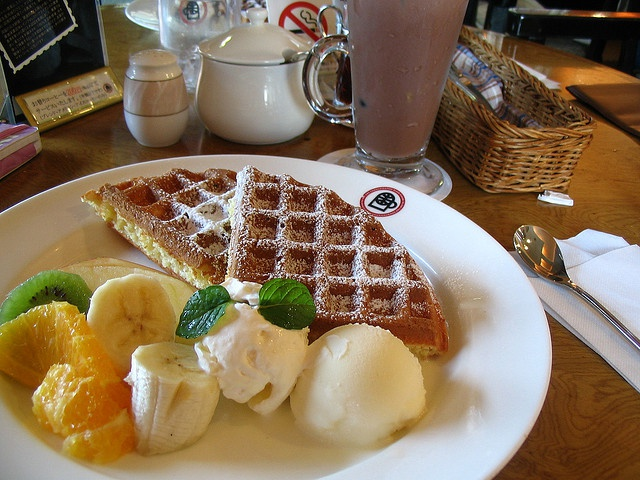Describe the objects in this image and their specific colors. I can see dining table in black, maroon, brown, and lavender tones, cake in black, maroon, lightgray, gray, and darkgray tones, cup in black, gray, brown, and maroon tones, orange in black, olive, orange, and tan tones, and banana in black, tan, olive, and lightgray tones in this image. 